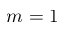Convert formula to latex. <formula><loc_0><loc_0><loc_500><loc_500>m = 1</formula> 